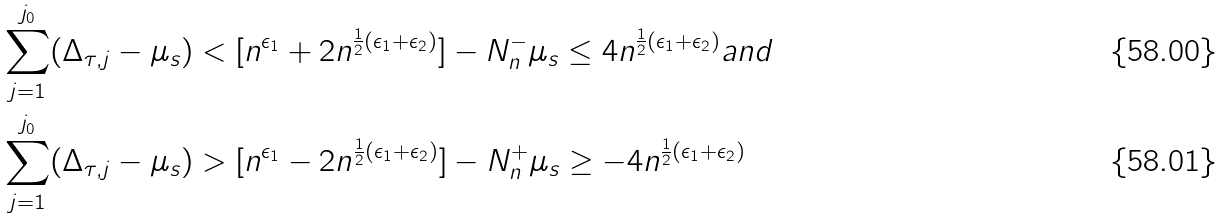<formula> <loc_0><loc_0><loc_500><loc_500>& \sum _ { j = 1 } ^ { j _ { 0 } } ( \Delta _ { \tau , j } - \mu _ { s } ) < [ n ^ { \epsilon _ { 1 } } + 2 n ^ { \frac { 1 } { 2 } ( \epsilon _ { 1 } + \epsilon _ { 2 } ) } ] - N _ { n } ^ { - } \mu _ { s } \leq 4 n ^ { \frac { 1 } { 2 } ( \epsilon _ { 1 } + \epsilon _ { 2 } ) } a n d \\ & \sum _ { j = 1 } ^ { j _ { 0 } } ( \Delta _ { \tau , j } - \mu _ { s } ) > [ n ^ { \epsilon _ { 1 } } - 2 n ^ { \frac { 1 } { 2 } ( \epsilon _ { 1 } + \epsilon _ { 2 } ) } ] - N _ { n } ^ { + } \mu _ { s } \geq - 4 n ^ { \frac { 1 } { 2 } ( \epsilon _ { 1 } + \epsilon _ { 2 } ) }</formula> 